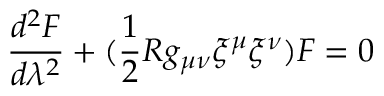Convert formula to latex. <formula><loc_0><loc_0><loc_500><loc_500>\frac { d ^ { 2 } F } { d \lambda ^ { 2 } } + ( \frac { 1 } { 2 } R g _ { \mu \nu } { \xi } ^ { \mu } { \xi } ^ { \nu } ) F = 0</formula> 